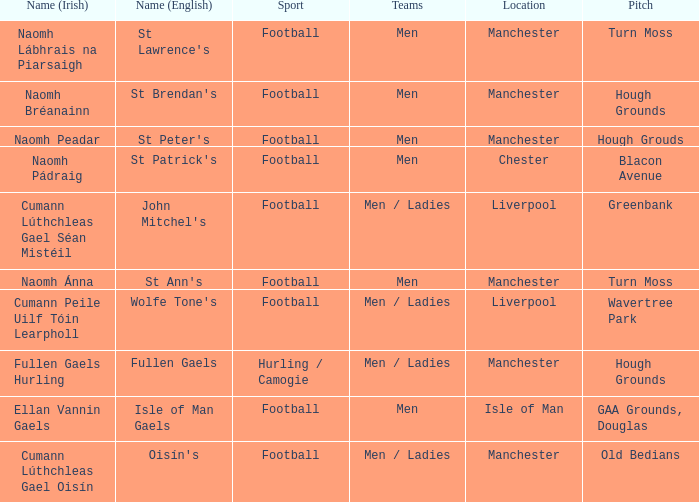What is the Location of the Old Bedians Pitch? Manchester. 